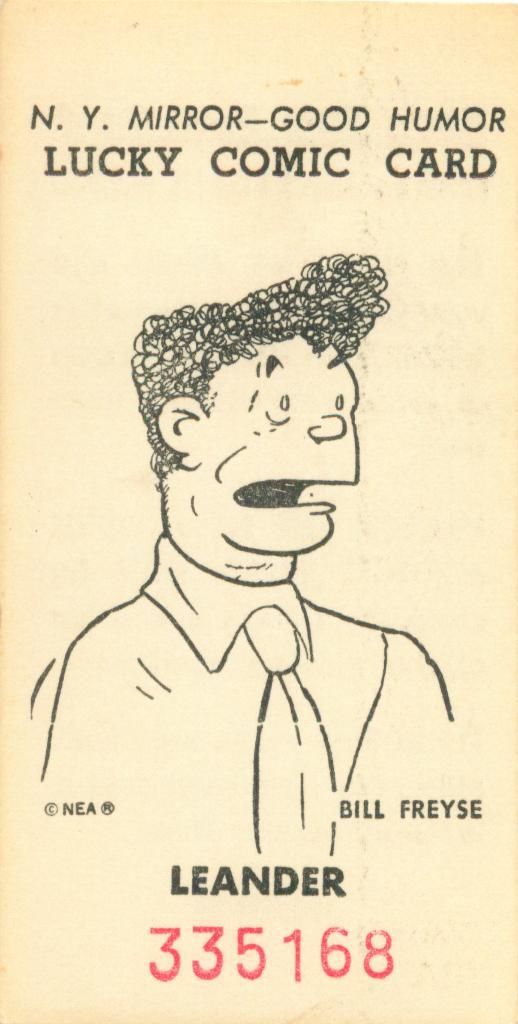What is the main subject of the image? There is a drawing of a person in the center of the image. What can be seen above the drawing of the person? There is text at the top of the image. What can be seen below the drawing of the person? There is text at the bottom of the image. Can you tell me how many knives are being used by the person in the image? There are no knives present in the image; it features a drawing of a person with text above and below. What type of snow can be seen falling in the image? There is no snow present in the image; it features a drawing of a person with text above and below. 